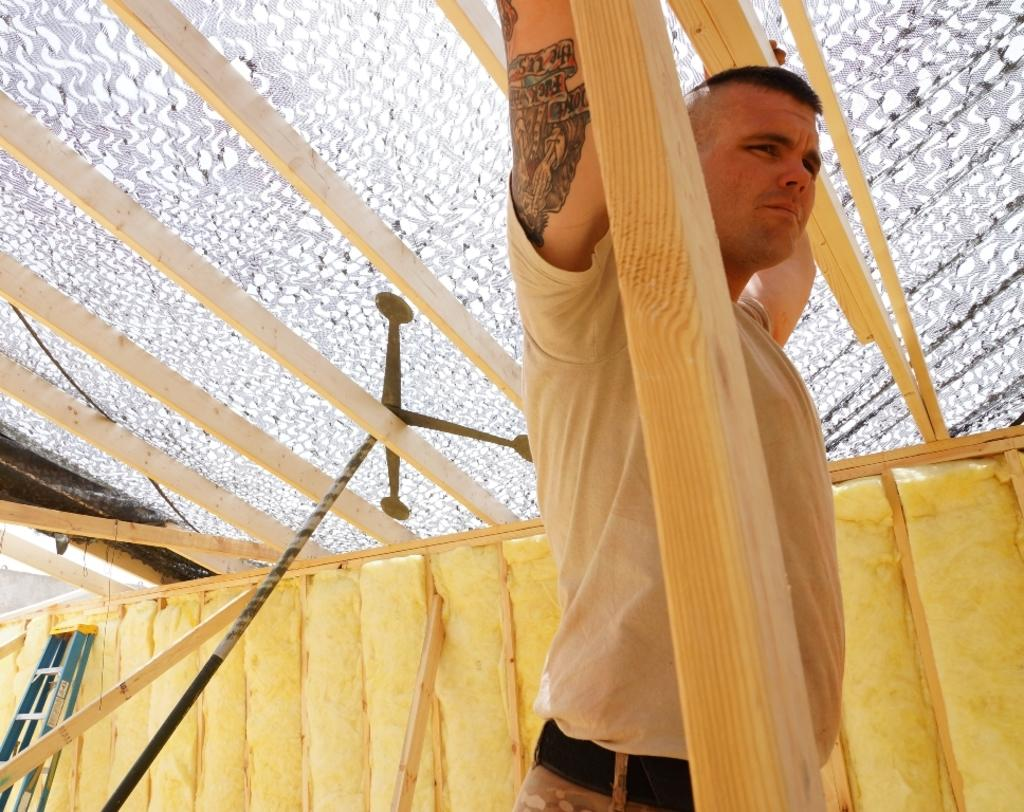Who is the main subject in the image? There is a man in the middle of the image. What materials are visible at the top of the image? There are wooden planks and glass at the top of the image. What object can be seen on the left side of the image? There is a ladder on the left side of the image. What type of prose is being written on the dock in the image? There is no dock or prose present in the image. How many turkeys can be seen in the image? There are no turkeys present in the image. 